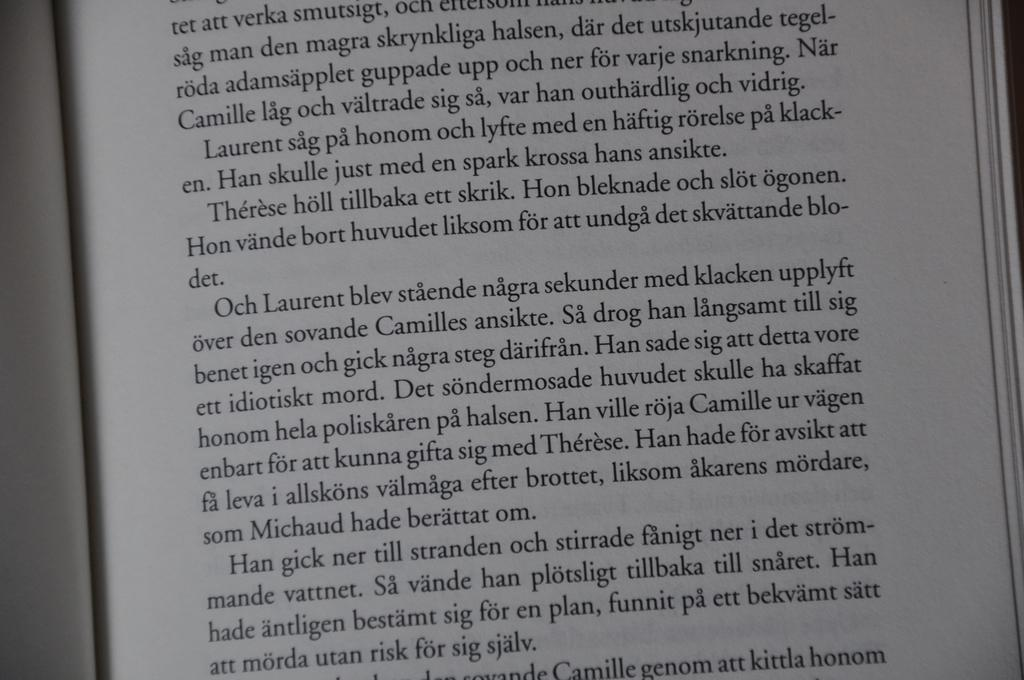What can be seen in the image related to reading or writing? There is a book and text on a paper in the image. Can you describe the book in the image? The book is the main object related to reading or writing in the image. What is the purpose of the text on the paper? The text on the paper may be for note-taking or writing down information. What type of quill is being used to write the text on the paper? There is no quill visible in the image; only the book and text on the paper are present. Are there any planes visible in the image? No, there are no planes present in the image. 